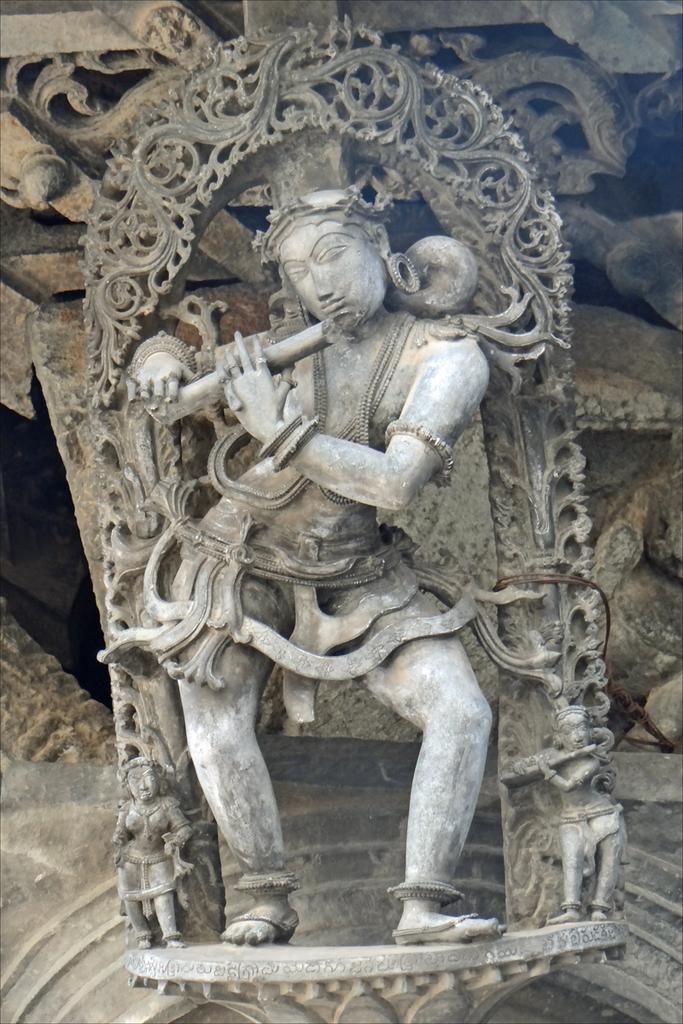Could you give a brief overview of what you see in this image? This picture is consists of a sculpture. 